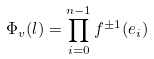Convert formula to latex. <formula><loc_0><loc_0><loc_500><loc_500>\Phi _ { v } ( l ) = \prod _ { i = 0 } ^ { n - 1 } f ^ { \pm 1 } ( e _ { i } )</formula> 